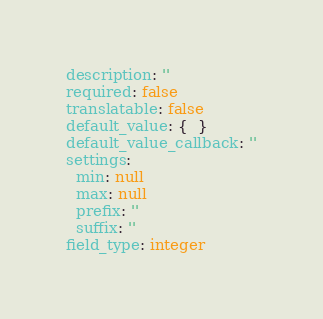Convert code to text. <code><loc_0><loc_0><loc_500><loc_500><_YAML_>description: ''
required: false
translatable: false
default_value: {  }
default_value_callback: ''
settings:
  min: null
  max: null
  prefix: ''
  suffix: ''
field_type: integer
</code> 